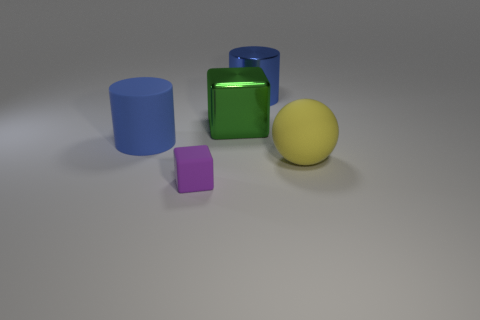Is there anything else that is the same size as the matte block?
Ensure brevity in your answer.  No. There is a small purple thing that is the same shape as the green shiny thing; what is its material?
Your response must be concise. Rubber. There is a large matte thing that is on the right side of the big matte thing that is on the left side of the blue metallic cylinder; what is its shape?
Your response must be concise. Sphere. Is the material of the blue cylinder that is behind the big blue rubber thing the same as the yellow ball?
Ensure brevity in your answer.  No. Is the number of blue objects on the right side of the blue shiny object the same as the number of tiny purple objects to the right of the large yellow sphere?
Keep it short and to the point. Yes. What is the material of the other cylinder that is the same color as the rubber cylinder?
Ensure brevity in your answer.  Metal. There is a big blue cylinder that is in front of the blue metal object; what number of large blue cylinders are to the right of it?
Keep it short and to the point. 1. Is the color of the large rubber cylinder to the left of the small purple matte cube the same as the large metallic cylinder that is right of the small rubber thing?
Your answer should be very brief. Yes. There is a yellow ball that is the same size as the blue matte cylinder; what is it made of?
Your response must be concise. Rubber. The thing that is right of the big blue thing on the right side of the blue thing left of the shiny block is what shape?
Provide a short and direct response. Sphere. 